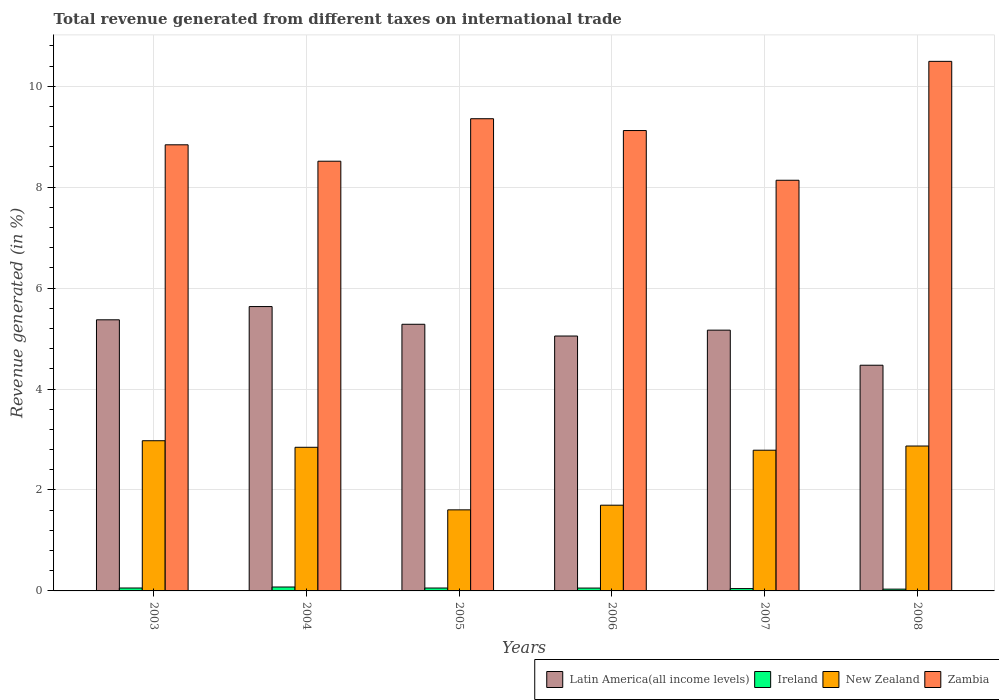How many groups of bars are there?
Keep it short and to the point. 6. Are the number of bars per tick equal to the number of legend labels?
Offer a terse response. Yes. Are the number of bars on each tick of the X-axis equal?
Keep it short and to the point. Yes. What is the label of the 2nd group of bars from the left?
Provide a short and direct response. 2004. In how many cases, is the number of bars for a given year not equal to the number of legend labels?
Provide a short and direct response. 0. What is the total revenue generated in Latin America(all income levels) in 2008?
Keep it short and to the point. 4.47. Across all years, what is the maximum total revenue generated in New Zealand?
Offer a very short reply. 2.98. Across all years, what is the minimum total revenue generated in Zambia?
Make the answer very short. 8.14. In which year was the total revenue generated in Latin America(all income levels) minimum?
Ensure brevity in your answer.  2008. What is the total total revenue generated in Zambia in the graph?
Ensure brevity in your answer.  54.46. What is the difference between the total revenue generated in Latin America(all income levels) in 2003 and that in 2004?
Provide a succinct answer. -0.26. What is the difference between the total revenue generated in Zambia in 2005 and the total revenue generated in New Zealand in 2003?
Your response must be concise. 6.38. What is the average total revenue generated in Latin America(all income levels) per year?
Provide a succinct answer. 5.16. In the year 2005, what is the difference between the total revenue generated in New Zealand and total revenue generated in Ireland?
Your response must be concise. 1.55. In how many years, is the total revenue generated in New Zealand greater than 9.6 %?
Provide a short and direct response. 0. What is the ratio of the total revenue generated in Latin America(all income levels) in 2006 to that in 2008?
Provide a short and direct response. 1.13. Is the difference between the total revenue generated in New Zealand in 2003 and 2008 greater than the difference between the total revenue generated in Ireland in 2003 and 2008?
Your response must be concise. Yes. What is the difference between the highest and the second highest total revenue generated in Ireland?
Ensure brevity in your answer.  0.02. What is the difference between the highest and the lowest total revenue generated in Zambia?
Keep it short and to the point. 2.36. In how many years, is the total revenue generated in Ireland greater than the average total revenue generated in Ireland taken over all years?
Your response must be concise. 4. Is the sum of the total revenue generated in Latin America(all income levels) in 2005 and 2008 greater than the maximum total revenue generated in Zambia across all years?
Your answer should be very brief. No. What does the 3rd bar from the left in 2003 represents?
Your answer should be compact. New Zealand. What does the 2nd bar from the right in 2006 represents?
Provide a short and direct response. New Zealand. Is it the case that in every year, the sum of the total revenue generated in Zambia and total revenue generated in Ireland is greater than the total revenue generated in New Zealand?
Your answer should be very brief. Yes. How many bars are there?
Keep it short and to the point. 24. What is the difference between two consecutive major ticks on the Y-axis?
Your answer should be very brief. 2. Where does the legend appear in the graph?
Keep it short and to the point. Bottom right. What is the title of the graph?
Give a very brief answer. Total revenue generated from different taxes on international trade. What is the label or title of the Y-axis?
Provide a succinct answer. Revenue generated (in %). What is the Revenue generated (in %) in Latin America(all income levels) in 2003?
Make the answer very short. 5.37. What is the Revenue generated (in %) of Ireland in 2003?
Your answer should be very brief. 0.06. What is the Revenue generated (in %) of New Zealand in 2003?
Ensure brevity in your answer.  2.98. What is the Revenue generated (in %) in Zambia in 2003?
Your answer should be compact. 8.84. What is the Revenue generated (in %) of Latin America(all income levels) in 2004?
Keep it short and to the point. 5.63. What is the Revenue generated (in %) of Ireland in 2004?
Your answer should be very brief. 0.08. What is the Revenue generated (in %) of New Zealand in 2004?
Provide a succinct answer. 2.85. What is the Revenue generated (in %) in Zambia in 2004?
Offer a terse response. 8.51. What is the Revenue generated (in %) of Latin America(all income levels) in 2005?
Your answer should be very brief. 5.28. What is the Revenue generated (in %) in Ireland in 2005?
Provide a succinct answer. 0.06. What is the Revenue generated (in %) of New Zealand in 2005?
Offer a terse response. 1.61. What is the Revenue generated (in %) of Zambia in 2005?
Offer a very short reply. 9.36. What is the Revenue generated (in %) of Latin America(all income levels) in 2006?
Ensure brevity in your answer.  5.05. What is the Revenue generated (in %) in Ireland in 2006?
Your answer should be very brief. 0.06. What is the Revenue generated (in %) of New Zealand in 2006?
Provide a short and direct response. 1.7. What is the Revenue generated (in %) in Zambia in 2006?
Provide a succinct answer. 9.12. What is the Revenue generated (in %) of Latin America(all income levels) in 2007?
Make the answer very short. 5.17. What is the Revenue generated (in %) of Ireland in 2007?
Your answer should be very brief. 0.05. What is the Revenue generated (in %) in New Zealand in 2007?
Offer a terse response. 2.79. What is the Revenue generated (in %) in Zambia in 2007?
Make the answer very short. 8.14. What is the Revenue generated (in %) in Latin America(all income levels) in 2008?
Make the answer very short. 4.47. What is the Revenue generated (in %) of Ireland in 2008?
Offer a terse response. 0.04. What is the Revenue generated (in %) of New Zealand in 2008?
Ensure brevity in your answer.  2.87. What is the Revenue generated (in %) of Zambia in 2008?
Provide a succinct answer. 10.49. Across all years, what is the maximum Revenue generated (in %) in Latin America(all income levels)?
Provide a succinct answer. 5.63. Across all years, what is the maximum Revenue generated (in %) in Ireland?
Offer a terse response. 0.08. Across all years, what is the maximum Revenue generated (in %) of New Zealand?
Your response must be concise. 2.98. Across all years, what is the maximum Revenue generated (in %) of Zambia?
Your answer should be compact. 10.49. Across all years, what is the minimum Revenue generated (in %) of Latin America(all income levels)?
Keep it short and to the point. 4.47. Across all years, what is the minimum Revenue generated (in %) in Ireland?
Your response must be concise. 0.04. Across all years, what is the minimum Revenue generated (in %) in New Zealand?
Provide a short and direct response. 1.61. Across all years, what is the minimum Revenue generated (in %) of Zambia?
Offer a terse response. 8.14. What is the total Revenue generated (in %) in Latin America(all income levels) in the graph?
Offer a terse response. 30.98. What is the total Revenue generated (in %) in Ireland in the graph?
Provide a succinct answer. 0.33. What is the total Revenue generated (in %) in New Zealand in the graph?
Ensure brevity in your answer.  14.78. What is the total Revenue generated (in %) in Zambia in the graph?
Provide a succinct answer. 54.46. What is the difference between the Revenue generated (in %) in Latin America(all income levels) in 2003 and that in 2004?
Ensure brevity in your answer.  -0.26. What is the difference between the Revenue generated (in %) of Ireland in 2003 and that in 2004?
Keep it short and to the point. -0.02. What is the difference between the Revenue generated (in %) of New Zealand in 2003 and that in 2004?
Your answer should be very brief. 0.13. What is the difference between the Revenue generated (in %) of Zambia in 2003 and that in 2004?
Make the answer very short. 0.33. What is the difference between the Revenue generated (in %) in Latin America(all income levels) in 2003 and that in 2005?
Ensure brevity in your answer.  0.09. What is the difference between the Revenue generated (in %) in Ireland in 2003 and that in 2005?
Offer a very short reply. 0. What is the difference between the Revenue generated (in %) of New Zealand in 2003 and that in 2005?
Offer a terse response. 1.37. What is the difference between the Revenue generated (in %) of Zambia in 2003 and that in 2005?
Your response must be concise. -0.52. What is the difference between the Revenue generated (in %) of Latin America(all income levels) in 2003 and that in 2006?
Your response must be concise. 0.32. What is the difference between the Revenue generated (in %) of Ireland in 2003 and that in 2006?
Provide a short and direct response. 0. What is the difference between the Revenue generated (in %) of New Zealand in 2003 and that in 2006?
Your answer should be very brief. 1.28. What is the difference between the Revenue generated (in %) of Zambia in 2003 and that in 2006?
Make the answer very short. -0.28. What is the difference between the Revenue generated (in %) in Latin America(all income levels) in 2003 and that in 2007?
Ensure brevity in your answer.  0.2. What is the difference between the Revenue generated (in %) in Ireland in 2003 and that in 2007?
Your answer should be compact. 0.01. What is the difference between the Revenue generated (in %) of New Zealand in 2003 and that in 2007?
Give a very brief answer. 0.19. What is the difference between the Revenue generated (in %) in Zambia in 2003 and that in 2007?
Give a very brief answer. 0.7. What is the difference between the Revenue generated (in %) in Latin America(all income levels) in 2003 and that in 2008?
Keep it short and to the point. 0.9. What is the difference between the Revenue generated (in %) of Ireland in 2003 and that in 2008?
Make the answer very short. 0.02. What is the difference between the Revenue generated (in %) of New Zealand in 2003 and that in 2008?
Your answer should be compact. 0.11. What is the difference between the Revenue generated (in %) in Zambia in 2003 and that in 2008?
Your answer should be very brief. -1.65. What is the difference between the Revenue generated (in %) in Latin America(all income levels) in 2004 and that in 2005?
Your answer should be very brief. 0.35. What is the difference between the Revenue generated (in %) of Ireland in 2004 and that in 2005?
Offer a very short reply. 0.02. What is the difference between the Revenue generated (in %) in New Zealand in 2004 and that in 2005?
Offer a very short reply. 1.24. What is the difference between the Revenue generated (in %) of Zambia in 2004 and that in 2005?
Provide a succinct answer. -0.84. What is the difference between the Revenue generated (in %) of Latin America(all income levels) in 2004 and that in 2006?
Your answer should be compact. 0.58. What is the difference between the Revenue generated (in %) of Ireland in 2004 and that in 2006?
Offer a very short reply. 0.02. What is the difference between the Revenue generated (in %) in New Zealand in 2004 and that in 2006?
Your answer should be very brief. 1.15. What is the difference between the Revenue generated (in %) in Zambia in 2004 and that in 2006?
Provide a short and direct response. -0.61. What is the difference between the Revenue generated (in %) in Latin America(all income levels) in 2004 and that in 2007?
Provide a succinct answer. 0.47. What is the difference between the Revenue generated (in %) of Ireland in 2004 and that in 2007?
Your answer should be very brief. 0.03. What is the difference between the Revenue generated (in %) in New Zealand in 2004 and that in 2007?
Provide a short and direct response. 0.06. What is the difference between the Revenue generated (in %) in Zambia in 2004 and that in 2007?
Make the answer very short. 0.38. What is the difference between the Revenue generated (in %) in Latin America(all income levels) in 2004 and that in 2008?
Provide a succinct answer. 1.16. What is the difference between the Revenue generated (in %) in Ireland in 2004 and that in 2008?
Keep it short and to the point. 0.04. What is the difference between the Revenue generated (in %) of New Zealand in 2004 and that in 2008?
Provide a short and direct response. -0.02. What is the difference between the Revenue generated (in %) in Zambia in 2004 and that in 2008?
Offer a terse response. -1.98. What is the difference between the Revenue generated (in %) in Latin America(all income levels) in 2005 and that in 2006?
Keep it short and to the point. 0.23. What is the difference between the Revenue generated (in %) in Ireland in 2005 and that in 2006?
Make the answer very short. 0. What is the difference between the Revenue generated (in %) in New Zealand in 2005 and that in 2006?
Your response must be concise. -0.09. What is the difference between the Revenue generated (in %) of Zambia in 2005 and that in 2006?
Your answer should be compact. 0.23. What is the difference between the Revenue generated (in %) in Latin America(all income levels) in 2005 and that in 2007?
Your response must be concise. 0.12. What is the difference between the Revenue generated (in %) in Ireland in 2005 and that in 2007?
Your answer should be compact. 0.01. What is the difference between the Revenue generated (in %) in New Zealand in 2005 and that in 2007?
Offer a very short reply. -1.18. What is the difference between the Revenue generated (in %) in Zambia in 2005 and that in 2007?
Offer a terse response. 1.22. What is the difference between the Revenue generated (in %) in Latin America(all income levels) in 2005 and that in 2008?
Offer a terse response. 0.81. What is the difference between the Revenue generated (in %) of Ireland in 2005 and that in 2008?
Ensure brevity in your answer.  0.02. What is the difference between the Revenue generated (in %) of New Zealand in 2005 and that in 2008?
Keep it short and to the point. -1.26. What is the difference between the Revenue generated (in %) of Zambia in 2005 and that in 2008?
Provide a short and direct response. -1.14. What is the difference between the Revenue generated (in %) in Latin America(all income levels) in 2006 and that in 2007?
Offer a terse response. -0.12. What is the difference between the Revenue generated (in %) of New Zealand in 2006 and that in 2007?
Give a very brief answer. -1.09. What is the difference between the Revenue generated (in %) of Zambia in 2006 and that in 2007?
Offer a very short reply. 0.98. What is the difference between the Revenue generated (in %) in Latin America(all income levels) in 2006 and that in 2008?
Keep it short and to the point. 0.58. What is the difference between the Revenue generated (in %) of Ireland in 2006 and that in 2008?
Your answer should be compact. 0.02. What is the difference between the Revenue generated (in %) of New Zealand in 2006 and that in 2008?
Give a very brief answer. -1.17. What is the difference between the Revenue generated (in %) in Zambia in 2006 and that in 2008?
Make the answer very short. -1.37. What is the difference between the Revenue generated (in %) of Latin America(all income levels) in 2007 and that in 2008?
Offer a very short reply. 0.69. What is the difference between the Revenue generated (in %) of Ireland in 2007 and that in 2008?
Provide a short and direct response. 0.01. What is the difference between the Revenue generated (in %) of New Zealand in 2007 and that in 2008?
Ensure brevity in your answer.  -0.08. What is the difference between the Revenue generated (in %) in Zambia in 2007 and that in 2008?
Keep it short and to the point. -2.36. What is the difference between the Revenue generated (in %) in Latin America(all income levels) in 2003 and the Revenue generated (in %) in Ireland in 2004?
Provide a succinct answer. 5.29. What is the difference between the Revenue generated (in %) in Latin America(all income levels) in 2003 and the Revenue generated (in %) in New Zealand in 2004?
Make the answer very short. 2.53. What is the difference between the Revenue generated (in %) of Latin America(all income levels) in 2003 and the Revenue generated (in %) of Zambia in 2004?
Ensure brevity in your answer.  -3.14. What is the difference between the Revenue generated (in %) of Ireland in 2003 and the Revenue generated (in %) of New Zealand in 2004?
Ensure brevity in your answer.  -2.79. What is the difference between the Revenue generated (in %) in Ireland in 2003 and the Revenue generated (in %) in Zambia in 2004?
Offer a terse response. -8.46. What is the difference between the Revenue generated (in %) of New Zealand in 2003 and the Revenue generated (in %) of Zambia in 2004?
Offer a terse response. -5.54. What is the difference between the Revenue generated (in %) in Latin America(all income levels) in 2003 and the Revenue generated (in %) in Ireland in 2005?
Offer a terse response. 5.31. What is the difference between the Revenue generated (in %) of Latin America(all income levels) in 2003 and the Revenue generated (in %) of New Zealand in 2005?
Keep it short and to the point. 3.77. What is the difference between the Revenue generated (in %) of Latin America(all income levels) in 2003 and the Revenue generated (in %) of Zambia in 2005?
Give a very brief answer. -3.98. What is the difference between the Revenue generated (in %) of Ireland in 2003 and the Revenue generated (in %) of New Zealand in 2005?
Ensure brevity in your answer.  -1.55. What is the difference between the Revenue generated (in %) of Ireland in 2003 and the Revenue generated (in %) of Zambia in 2005?
Ensure brevity in your answer.  -9.3. What is the difference between the Revenue generated (in %) in New Zealand in 2003 and the Revenue generated (in %) in Zambia in 2005?
Provide a succinct answer. -6.38. What is the difference between the Revenue generated (in %) in Latin America(all income levels) in 2003 and the Revenue generated (in %) in Ireland in 2006?
Provide a succinct answer. 5.32. What is the difference between the Revenue generated (in %) in Latin America(all income levels) in 2003 and the Revenue generated (in %) in New Zealand in 2006?
Offer a terse response. 3.67. What is the difference between the Revenue generated (in %) of Latin America(all income levels) in 2003 and the Revenue generated (in %) of Zambia in 2006?
Offer a very short reply. -3.75. What is the difference between the Revenue generated (in %) in Ireland in 2003 and the Revenue generated (in %) in New Zealand in 2006?
Ensure brevity in your answer.  -1.64. What is the difference between the Revenue generated (in %) of Ireland in 2003 and the Revenue generated (in %) of Zambia in 2006?
Offer a very short reply. -9.06. What is the difference between the Revenue generated (in %) in New Zealand in 2003 and the Revenue generated (in %) in Zambia in 2006?
Make the answer very short. -6.15. What is the difference between the Revenue generated (in %) in Latin America(all income levels) in 2003 and the Revenue generated (in %) in Ireland in 2007?
Offer a terse response. 5.33. What is the difference between the Revenue generated (in %) of Latin America(all income levels) in 2003 and the Revenue generated (in %) of New Zealand in 2007?
Your answer should be compact. 2.58. What is the difference between the Revenue generated (in %) of Latin America(all income levels) in 2003 and the Revenue generated (in %) of Zambia in 2007?
Your answer should be very brief. -2.77. What is the difference between the Revenue generated (in %) in Ireland in 2003 and the Revenue generated (in %) in New Zealand in 2007?
Keep it short and to the point. -2.73. What is the difference between the Revenue generated (in %) of Ireland in 2003 and the Revenue generated (in %) of Zambia in 2007?
Offer a very short reply. -8.08. What is the difference between the Revenue generated (in %) in New Zealand in 2003 and the Revenue generated (in %) in Zambia in 2007?
Provide a short and direct response. -5.16. What is the difference between the Revenue generated (in %) in Latin America(all income levels) in 2003 and the Revenue generated (in %) in Ireland in 2008?
Your answer should be compact. 5.34. What is the difference between the Revenue generated (in %) in Latin America(all income levels) in 2003 and the Revenue generated (in %) in New Zealand in 2008?
Keep it short and to the point. 2.5. What is the difference between the Revenue generated (in %) of Latin America(all income levels) in 2003 and the Revenue generated (in %) of Zambia in 2008?
Provide a short and direct response. -5.12. What is the difference between the Revenue generated (in %) in Ireland in 2003 and the Revenue generated (in %) in New Zealand in 2008?
Provide a short and direct response. -2.81. What is the difference between the Revenue generated (in %) of Ireland in 2003 and the Revenue generated (in %) of Zambia in 2008?
Ensure brevity in your answer.  -10.43. What is the difference between the Revenue generated (in %) in New Zealand in 2003 and the Revenue generated (in %) in Zambia in 2008?
Ensure brevity in your answer.  -7.52. What is the difference between the Revenue generated (in %) of Latin America(all income levels) in 2004 and the Revenue generated (in %) of Ireland in 2005?
Give a very brief answer. 5.58. What is the difference between the Revenue generated (in %) of Latin America(all income levels) in 2004 and the Revenue generated (in %) of New Zealand in 2005?
Provide a succinct answer. 4.03. What is the difference between the Revenue generated (in %) in Latin America(all income levels) in 2004 and the Revenue generated (in %) in Zambia in 2005?
Keep it short and to the point. -3.72. What is the difference between the Revenue generated (in %) of Ireland in 2004 and the Revenue generated (in %) of New Zealand in 2005?
Your answer should be very brief. -1.53. What is the difference between the Revenue generated (in %) of Ireland in 2004 and the Revenue generated (in %) of Zambia in 2005?
Keep it short and to the point. -9.28. What is the difference between the Revenue generated (in %) of New Zealand in 2004 and the Revenue generated (in %) of Zambia in 2005?
Offer a very short reply. -6.51. What is the difference between the Revenue generated (in %) in Latin America(all income levels) in 2004 and the Revenue generated (in %) in Ireland in 2006?
Provide a succinct answer. 5.58. What is the difference between the Revenue generated (in %) in Latin America(all income levels) in 2004 and the Revenue generated (in %) in New Zealand in 2006?
Provide a succinct answer. 3.94. What is the difference between the Revenue generated (in %) in Latin America(all income levels) in 2004 and the Revenue generated (in %) in Zambia in 2006?
Your answer should be compact. -3.49. What is the difference between the Revenue generated (in %) in Ireland in 2004 and the Revenue generated (in %) in New Zealand in 2006?
Keep it short and to the point. -1.62. What is the difference between the Revenue generated (in %) in Ireland in 2004 and the Revenue generated (in %) in Zambia in 2006?
Make the answer very short. -9.04. What is the difference between the Revenue generated (in %) in New Zealand in 2004 and the Revenue generated (in %) in Zambia in 2006?
Provide a succinct answer. -6.28. What is the difference between the Revenue generated (in %) in Latin America(all income levels) in 2004 and the Revenue generated (in %) in Ireland in 2007?
Provide a succinct answer. 5.59. What is the difference between the Revenue generated (in %) of Latin America(all income levels) in 2004 and the Revenue generated (in %) of New Zealand in 2007?
Your answer should be very brief. 2.85. What is the difference between the Revenue generated (in %) of Latin America(all income levels) in 2004 and the Revenue generated (in %) of Zambia in 2007?
Offer a very short reply. -2.5. What is the difference between the Revenue generated (in %) of Ireland in 2004 and the Revenue generated (in %) of New Zealand in 2007?
Your answer should be very brief. -2.71. What is the difference between the Revenue generated (in %) of Ireland in 2004 and the Revenue generated (in %) of Zambia in 2007?
Your answer should be compact. -8.06. What is the difference between the Revenue generated (in %) of New Zealand in 2004 and the Revenue generated (in %) of Zambia in 2007?
Provide a succinct answer. -5.29. What is the difference between the Revenue generated (in %) in Latin America(all income levels) in 2004 and the Revenue generated (in %) in Ireland in 2008?
Make the answer very short. 5.6. What is the difference between the Revenue generated (in %) of Latin America(all income levels) in 2004 and the Revenue generated (in %) of New Zealand in 2008?
Provide a succinct answer. 2.76. What is the difference between the Revenue generated (in %) of Latin America(all income levels) in 2004 and the Revenue generated (in %) of Zambia in 2008?
Keep it short and to the point. -4.86. What is the difference between the Revenue generated (in %) in Ireland in 2004 and the Revenue generated (in %) in New Zealand in 2008?
Offer a terse response. -2.79. What is the difference between the Revenue generated (in %) of Ireland in 2004 and the Revenue generated (in %) of Zambia in 2008?
Your answer should be very brief. -10.41. What is the difference between the Revenue generated (in %) of New Zealand in 2004 and the Revenue generated (in %) of Zambia in 2008?
Your answer should be compact. -7.65. What is the difference between the Revenue generated (in %) in Latin America(all income levels) in 2005 and the Revenue generated (in %) in Ireland in 2006?
Provide a short and direct response. 5.23. What is the difference between the Revenue generated (in %) of Latin America(all income levels) in 2005 and the Revenue generated (in %) of New Zealand in 2006?
Offer a terse response. 3.58. What is the difference between the Revenue generated (in %) in Latin America(all income levels) in 2005 and the Revenue generated (in %) in Zambia in 2006?
Your answer should be very brief. -3.84. What is the difference between the Revenue generated (in %) in Ireland in 2005 and the Revenue generated (in %) in New Zealand in 2006?
Keep it short and to the point. -1.64. What is the difference between the Revenue generated (in %) in Ireland in 2005 and the Revenue generated (in %) in Zambia in 2006?
Your response must be concise. -9.06. What is the difference between the Revenue generated (in %) of New Zealand in 2005 and the Revenue generated (in %) of Zambia in 2006?
Offer a very short reply. -7.52. What is the difference between the Revenue generated (in %) of Latin America(all income levels) in 2005 and the Revenue generated (in %) of Ireland in 2007?
Give a very brief answer. 5.24. What is the difference between the Revenue generated (in %) in Latin America(all income levels) in 2005 and the Revenue generated (in %) in New Zealand in 2007?
Give a very brief answer. 2.5. What is the difference between the Revenue generated (in %) in Latin America(all income levels) in 2005 and the Revenue generated (in %) in Zambia in 2007?
Your answer should be very brief. -2.85. What is the difference between the Revenue generated (in %) in Ireland in 2005 and the Revenue generated (in %) in New Zealand in 2007?
Keep it short and to the point. -2.73. What is the difference between the Revenue generated (in %) of Ireland in 2005 and the Revenue generated (in %) of Zambia in 2007?
Offer a very short reply. -8.08. What is the difference between the Revenue generated (in %) in New Zealand in 2005 and the Revenue generated (in %) in Zambia in 2007?
Make the answer very short. -6.53. What is the difference between the Revenue generated (in %) in Latin America(all income levels) in 2005 and the Revenue generated (in %) in Ireland in 2008?
Provide a succinct answer. 5.25. What is the difference between the Revenue generated (in %) of Latin America(all income levels) in 2005 and the Revenue generated (in %) of New Zealand in 2008?
Your answer should be compact. 2.41. What is the difference between the Revenue generated (in %) of Latin America(all income levels) in 2005 and the Revenue generated (in %) of Zambia in 2008?
Provide a short and direct response. -5.21. What is the difference between the Revenue generated (in %) in Ireland in 2005 and the Revenue generated (in %) in New Zealand in 2008?
Your answer should be very brief. -2.81. What is the difference between the Revenue generated (in %) in Ireland in 2005 and the Revenue generated (in %) in Zambia in 2008?
Offer a very short reply. -10.43. What is the difference between the Revenue generated (in %) in New Zealand in 2005 and the Revenue generated (in %) in Zambia in 2008?
Provide a short and direct response. -8.89. What is the difference between the Revenue generated (in %) in Latin America(all income levels) in 2006 and the Revenue generated (in %) in Ireland in 2007?
Give a very brief answer. 5. What is the difference between the Revenue generated (in %) of Latin America(all income levels) in 2006 and the Revenue generated (in %) of New Zealand in 2007?
Your response must be concise. 2.26. What is the difference between the Revenue generated (in %) in Latin America(all income levels) in 2006 and the Revenue generated (in %) in Zambia in 2007?
Give a very brief answer. -3.09. What is the difference between the Revenue generated (in %) of Ireland in 2006 and the Revenue generated (in %) of New Zealand in 2007?
Make the answer very short. -2.73. What is the difference between the Revenue generated (in %) in Ireland in 2006 and the Revenue generated (in %) in Zambia in 2007?
Ensure brevity in your answer.  -8.08. What is the difference between the Revenue generated (in %) in New Zealand in 2006 and the Revenue generated (in %) in Zambia in 2007?
Provide a short and direct response. -6.44. What is the difference between the Revenue generated (in %) in Latin America(all income levels) in 2006 and the Revenue generated (in %) in Ireland in 2008?
Offer a very short reply. 5.01. What is the difference between the Revenue generated (in %) of Latin America(all income levels) in 2006 and the Revenue generated (in %) of New Zealand in 2008?
Make the answer very short. 2.18. What is the difference between the Revenue generated (in %) in Latin America(all income levels) in 2006 and the Revenue generated (in %) in Zambia in 2008?
Make the answer very short. -5.44. What is the difference between the Revenue generated (in %) of Ireland in 2006 and the Revenue generated (in %) of New Zealand in 2008?
Ensure brevity in your answer.  -2.81. What is the difference between the Revenue generated (in %) of Ireland in 2006 and the Revenue generated (in %) of Zambia in 2008?
Provide a succinct answer. -10.44. What is the difference between the Revenue generated (in %) in New Zealand in 2006 and the Revenue generated (in %) in Zambia in 2008?
Make the answer very short. -8.79. What is the difference between the Revenue generated (in %) of Latin America(all income levels) in 2007 and the Revenue generated (in %) of Ireland in 2008?
Keep it short and to the point. 5.13. What is the difference between the Revenue generated (in %) of Latin America(all income levels) in 2007 and the Revenue generated (in %) of New Zealand in 2008?
Your answer should be compact. 2.3. What is the difference between the Revenue generated (in %) of Latin America(all income levels) in 2007 and the Revenue generated (in %) of Zambia in 2008?
Provide a short and direct response. -5.33. What is the difference between the Revenue generated (in %) in Ireland in 2007 and the Revenue generated (in %) in New Zealand in 2008?
Provide a short and direct response. -2.82. What is the difference between the Revenue generated (in %) of Ireland in 2007 and the Revenue generated (in %) of Zambia in 2008?
Make the answer very short. -10.45. What is the difference between the Revenue generated (in %) in New Zealand in 2007 and the Revenue generated (in %) in Zambia in 2008?
Provide a short and direct response. -7.7. What is the average Revenue generated (in %) in Latin America(all income levels) per year?
Keep it short and to the point. 5.16. What is the average Revenue generated (in %) of Ireland per year?
Provide a succinct answer. 0.06. What is the average Revenue generated (in %) in New Zealand per year?
Your answer should be very brief. 2.46. What is the average Revenue generated (in %) of Zambia per year?
Offer a very short reply. 9.08. In the year 2003, what is the difference between the Revenue generated (in %) in Latin America(all income levels) and Revenue generated (in %) in Ireland?
Ensure brevity in your answer.  5.31. In the year 2003, what is the difference between the Revenue generated (in %) in Latin America(all income levels) and Revenue generated (in %) in New Zealand?
Your answer should be very brief. 2.4. In the year 2003, what is the difference between the Revenue generated (in %) of Latin America(all income levels) and Revenue generated (in %) of Zambia?
Give a very brief answer. -3.47. In the year 2003, what is the difference between the Revenue generated (in %) of Ireland and Revenue generated (in %) of New Zealand?
Your answer should be compact. -2.92. In the year 2003, what is the difference between the Revenue generated (in %) of Ireland and Revenue generated (in %) of Zambia?
Your answer should be very brief. -8.78. In the year 2003, what is the difference between the Revenue generated (in %) in New Zealand and Revenue generated (in %) in Zambia?
Your response must be concise. -5.86. In the year 2004, what is the difference between the Revenue generated (in %) in Latin America(all income levels) and Revenue generated (in %) in Ireland?
Your answer should be compact. 5.56. In the year 2004, what is the difference between the Revenue generated (in %) in Latin America(all income levels) and Revenue generated (in %) in New Zealand?
Your answer should be compact. 2.79. In the year 2004, what is the difference between the Revenue generated (in %) in Latin America(all income levels) and Revenue generated (in %) in Zambia?
Your answer should be very brief. -2.88. In the year 2004, what is the difference between the Revenue generated (in %) of Ireland and Revenue generated (in %) of New Zealand?
Offer a terse response. -2.77. In the year 2004, what is the difference between the Revenue generated (in %) of Ireland and Revenue generated (in %) of Zambia?
Provide a short and direct response. -8.44. In the year 2004, what is the difference between the Revenue generated (in %) in New Zealand and Revenue generated (in %) in Zambia?
Offer a very short reply. -5.67. In the year 2005, what is the difference between the Revenue generated (in %) in Latin America(all income levels) and Revenue generated (in %) in Ireland?
Provide a short and direct response. 5.23. In the year 2005, what is the difference between the Revenue generated (in %) in Latin America(all income levels) and Revenue generated (in %) in New Zealand?
Provide a succinct answer. 3.68. In the year 2005, what is the difference between the Revenue generated (in %) in Latin America(all income levels) and Revenue generated (in %) in Zambia?
Provide a succinct answer. -4.07. In the year 2005, what is the difference between the Revenue generated (in %) in Ireland and Revenue generated (in %) in New Zealand?
Your answer should be compact. -1.55. In the year 2005, what is the difference between the Revenue generated (in %) of Ireland and Revenue generated (in %) of Zambia?
Provide a succinct answer. -9.3. In the year 2005, what is the difference between the Revenue generated (in %) in New Zealand and Revenue generated (in %) in Zambia?
Your answer should be compact. -7.75. In the year 2006, what is the difference between the Revenue generated (in %) of Latin America(all income levels) and Revenue generated (in %) of Ireland?
Provide a short and direct response. 4.99. In the year 2006, what is the difference between the Revenue generated (in %) of Latin America(all income levels) and Revenue generated (in %) of New Zealand?
Offer a very short reply. 3.35. In the year 2006, what is the difference between the Revenue generated (in %) of Latin America(all income levels) and Revenue generated (in %) of Zambia?
Offer a terse response. -4.07. In the year 2006, what is the difference between the Revenue generated (in %) in Ireland and Revenue generated (in %) in New Zealand?
Your response must be concise. -1.64. In the year 2006, what is the difference between the Revenue generated (in %) of Ireland and Revenue generated (in %) of Zambia?
Provide a succinct answer. -9.06. In the year 2006, what is the difference between the Revenue generated (in %) in New Zealand and Revenue generated (in %) in Zambia?
Give a very brief answer. -7.42. In the year 2007, what is the difference between the Revenue generated (in %) of Latin America(all income levels) and Revenue generated (in %) of Ireland?
Keep it short and to the point. 5.12. In the year 2007, what is the difference between the Revenue generated (in %) in Latin America(all income levels) and Revenue generated (in %) in New Zealand?
Keep it short and to the point. 2.38. In the year 2007, what is the difference between the Revenue generated (in %) of Latin America(all income levels) and Revenue generated (in %) of Zambia?
Ensure brevity in your answer.  -2.97. In the year 2007, what is the difference between the Revenue generated (in %) in Ireland and Revenue generated (in %) in New Zealand?
Offer a terse response. -2.74. In the year 2007, what is the difference between the Revenue generated (in %) of Ireland and Revenue generated (in %) of Zambia?
Provide a short and direct response. -8.09. In the year 2007, what is the difference between the Revenue generated (in %) of New Zealand and Revenue generated (in %) of Zambia?
Your answer should be very brief. -5.35. In the year 2008, what is the difference between the Revenue generated (in %) of Latin America(all income levels) and Revenue generated (in %) of Ireland?
Offer a very short reply. 4.44. In the year 2008, what is the difference between the Revenue generated (in %) of Latin America(all income levels) and Revenue generated (in %) of New Zealand?
Ensure brevity in your answer.  1.6. In the year 2008, what is the difference between the Revenue generated (in %) of Latin America(all income levels) and Revenue generated (in %) of Zambia?
Provide a succinct answer. -6.02. In the year 2008, what is the difference between the Revenue generated (in %) in Ireland and Revenue generated (in %) in New Zealand?
Your answer should be compact. -2.84. In the year 2008, what is the difference between the Revenue generated (in %) in Ireland and Revenue generated (in %) in Zambia?
Ensure brevity in your answer.  -10.46. In the year 2008, what is the difference between the Revenue generated (in %) of New Zealand and Revenue generated (in %) of Zambia?
Make the answer very short. -7.62. What is the ratio of the Revenue generated (in %) in Latin America(all income levels) in 2003 to that in 2004?
Your response must be concise. 0.95. What is the ratio of the Revenue generated (in %) in Ireland in 2003 to that in 2004?
Provide a succinct answer. 0.74. What is the ratio of the Revenue generated (in %) of New Zealand in 2003 to that in 2004?
Your answer should be compact. 1.05. What is the ratio of the Revenue generated (in %) in Zambia in 2003 to that in 2004?
Offer a terse response. 1.04. What is the ratio of the Revenue generated (in %) in Latin America(all income levels) in 2003 to that in 2005?
Your answer should be very brief. 1.02. What is the ratio of the Revenue generated (in %) in New Zealand in 2003 to that in 2005?
Your answer should be compact. 1.85. What is the ratio of the Revenue generated (in %) in Zambia in 2003 to that in 2005?
Your response must be concise. 0.94. What is the ratio of the Revenue generated (in %) of Latin America(all income levels) in 2003 to that in 2006?
Make the answer very short. 1.06. What is the ratio of the Revenue generated (in %) of Ireland in 2003 to that in 2006?
Your answer should be very brief. 1.02. What is the ratio of the Revenue generated (in %) of New Zealand in 2003 to that in 2006?
Your response must be concise. 1.75. What is the ratio of the Revenue generated (in %) of Latin America(all income levels) in 2003 to that in 2007?
Make the answer very short. 1.04. What is the ratio of the Revenue generated (in %) of Ireland in 2003 to that in 2007?
Make the answer very short. 1.24. What is the ratio of the Revenue generated (in %) in New Zealand in 2003 to that in 2007?
Offer a terse response. 1.07. What is the ratio of the Revenue generated (in %) in Zambia in 2003 to that in 2007?
Ensure brevity in your answer.  1.09. What is the ratio of the Revenue generated (in %) in Latin America(all income levels) in 2003 to that in 2008?
Offer a terse response. 1.2. What is the ratio of the Revenue generated (in %) in Ireland in 2003 to that in 2008?
Ensure brevity in your answer.  1.62. What is the ratio of the Revenue generated (in %) in New Zealand in 2003 to that in 2008?
Your answer should be very brief. 1.04. What is the ratio of the Revenue generated (in %) of Zambia in 2003 to that in 2008?
Your answer should be compact. 0.84. What is the ratio of the Revenue generated (in %) of Latin America(all income levels) in 2004 to that in 2005?
Give a very brief answer. 1.07. What is the ratio of the Revenue generated (in %) of Ireland in 2004 to that in 2005?
Your answer should be very brief. 1.35. What is the ratio of the Revenue generated (in %) of New Zealand in 2004 to that in 2005?
Your response must be concise. 1.77. What is the ratio of the Revenue generated (in %) in Zambia in 2004 to that in 2005?
Offer a terse response. 0.91. What is the ratio of the Revenue generated (in %) in Latin America(all income levels) in 2004 to that in 2006?
Keep it short and to the point. 1.12. What is the ratio of the Revenue generated (in %) in Ireland in 2004 to that in 2006?
Keep it short and to the point. 1.38. What is the ratio of the Revenue generated (in %) of New Zealand in 2004 to that in 2006?
Your answer should be compact. 1.68. What is the ratio of the Revenue generated (in %) in Zambia in 2004 to that in 2006?
Provide a succinct answer. 0.93. What is the ratio of the Revenue generated (in %) in Latin America(all income levels) in 2004 to that in 2007?
Offer a very short reply. 1.09. What is the ratio of the Revenue generated (in %) of Ireland in 2004 to that in 2007?
Offer a terse response. 1.67. What is the ratio of the Revenue generated (in %) of New Zealand in 2004 to that in 2007?
Your answer should be compact. 1.02. What is the ratio of the Revenue generated (in %) in Zambia in 2004 to that in 2007?
Offer a terse response. 1.05. What is the ratio of the Revenue generated (in %) in Latin America(all income levels) in 2004 to that in 2008?
Your answer should be compact. 1.26. What is the ratio of the Revenue generated (in %) of Ireland in 2004 to that in 2008?
Offer a very short reply. 2.19. What is the ratio of the Revenue generated (in %) of New Zealand in 2004 to that in 2008?
Your answer should be very brief. 0.99. What is the ratio of the Revenue generated (in %) in Zambia in 2004 to that in 2008?
Your answer should be very brief. 0.81. What is the ratio of the Revenue generated (in %) of Latin America(all income levels) in 2005 to that in 2006?
Your answer should be compact. 1.05. What is the ratio of the Revenue generated (in %) of Ireland in 2005 to that in 2006?
Offer a very short reply. 1.02. What is the ratio of the Revenue generated (in %) in New Zealand in 2005 to that in 2006?
Provide a succinct answer. 0.95. What is the ratio of the Revenue generated (in %) of Zambia in 2005 to that in 2006?
Your response must be concise. 1.03. What is the ratio of the Revenue generated (in %) of Latin America(all income levels) in 2005 to that in 2007?
Your answer should be compact. 1.02. What is the ratio of the Revenue generated (in %) in Ireland in 2005 to that in 2007?
Your answer should be compact. 1.24. What is the ratio of the Revenue generated (in %) in New Zealand in 2005 to that in 2007?
Provide a succinct answer. 0.58. What is the ratio of the Revenue generated (in %) of Zambia in 2005 to that in 2007?
Offer a very short reply. 1.15. What is the ratio of the Revenue generated (in %) in Latin America(all income levels) in 2005 to that in 2008?
Keep it short and to the point. 1.18. What is the ratio of the Revenue generated (in %) in Ireland in 2005 to that in 2008?
Your answer should be compact. 1.62. What is the ratio of the Revenue generated (in %) in New Zealand in 2005 to that in 2008?
Offer a terse response. 0.56. What is the ratio of the Revenue generated (in %) in Zambia in 2005 to that in 2008?
Your answer should be compact. 0.89. What is the ratio of the Revenue generated (in %) in Latin America(all income levels) in 2006 to that in 2007?
Your response must be concise. 0.98. What is the ratio of the Revenue generated (in %) in Ireland in 2006 to that in 2007?
Make the answer very short. 1.22. What is the ratio of the Revenue generated (in %) in New Zealand in 2006 to that in 2007?
Your response must be concise. 0.61. What is the ratio of the Revenue generated (in %) of Zambia in 2006 to that in 2007?
Your answer should be very brief. 1.12. What is the ratio of the Revenue generated (in %) in Latin America(all income levels) in 2006 to that in 2008?
Provide a short and direct response. 1.13. What is the ratio of the Revenue generated (in %) in Ireland in 2006 to that in 2008?
Offer a terse response. 1.59. What is the ratio of the Revenue generated (in %) of New Zealand in 2006 to that in 2008?
Provide a succinct answer. 0.59. What is the ratio of the Revenue generated (in %) of Zambia in 2006 to that in 2008?
Offer a very short reply. 0.87. What is the ratio of the Revenue generated (in %) of Latin America(all income levels) in 2007 to that in 2008?
Your answer should be very brief. 1.16. What is the ratio of the Revenue generated (in %) in Ireland in 2007 to that in 2008?
Your response must be concise. 1.31. What is the ratio of the Revenue generated (in %) of New Zealand in 2007 to that in 2008?
Offer a very short reply. 0.97. What is the ratio of the Revenue generated (in %) of Zambia in 2007 to that in 2008?
Provide a succinct answer. 0.78. What is the difference between the highest and the second highest Revenue generated (in %) of Latin America(all income levels)?
Make the answer very short. 0.26. What is the difference between the highest and the second highest Revenue generated (in %) in Ireland?
Provide a short and direct response. 0.02. What is the difference between the highest and the second highest Revenue generated (in %) in New Zealand?
Offer a terse response. 0.11. What is the difference between the highest and the second highest Revenue generated (in %) of Zambia?
Provide a succinct answer. 1.14. What is the difference between the highest and the lowest Revenue generated (in %) of Latin America(all income levels)?
Offer a very short reply. 1.16. What is the difference between the highest and the lowest Revenue generated (in %) in Ireland?
Your response must be concise. 0.04. What is the difference between the highest and the lowest Revenue generated (in %) of New Zealand?
Make the answer very short. 1.37. What is the difference between the highest and the lowest Revenue generated (in %) in Zambia?
Offer a terse response. 2.36. 